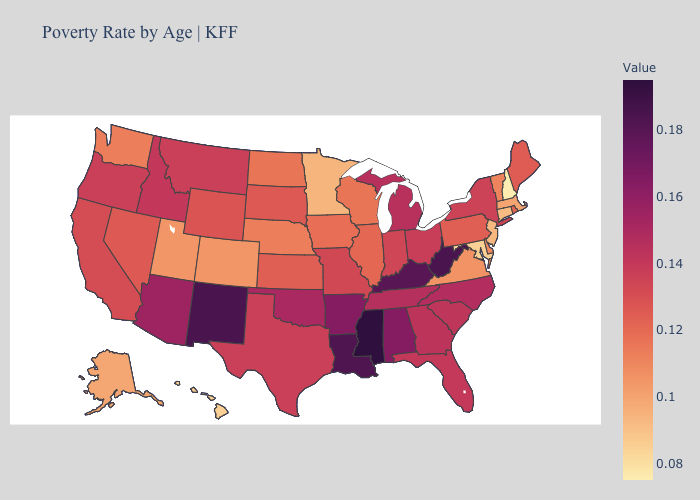Among the states that border Minnesota , which have the highest value?
Write a very short answer. South Dakota. Does Wyoming have the highest value in the West?
Give a very brief answer. No. Does Mississippi have the highest value in the USA?
Short answer required. Yes. Does the map have missing data?
Short answer required. No. Does Michigan have the highest value in the MidWest?
Be succinct. Yes. Is the legend a continuous bar?
Short answer required. Yes. 